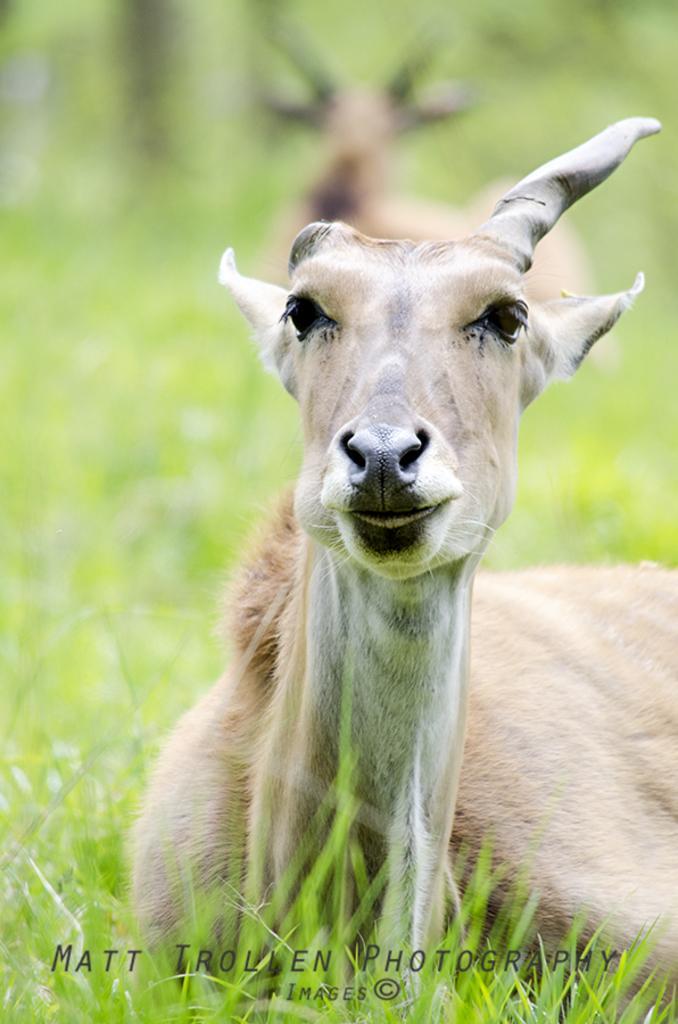How would you summarize this image in a sentence or two? In the image there are two deers sitting on the grassland. 